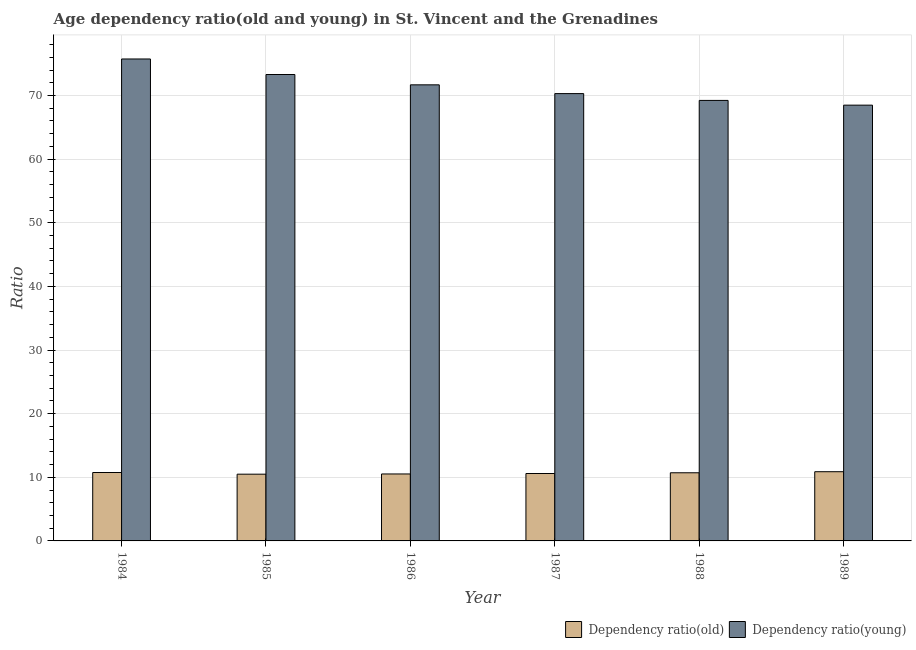Are the number of bars on each tick of the X-axis equal?
Make the answer very short. Yes. How many bars are there on the 6th tick from the right?
Your response must be concise. 2. What is the label of the 5th group of bars from the left?
Provide a short and direct response. 1988. In how many cases, is the number of bars for a given year not equal to the number of legend labels?
Make the answer very short. 0. What is the age dependency ratio(young) in 1987?
Your answer should be compact. 70.3. Across all years, what is the maximum age dependency ratio(old)?
Give a very brief answer. 10.88. Across all years, what is the minimum age dependency ratio(young)?
Offer a very short reply. 68.48. In which year was the age dependency ratio(old) minimum?
Offer a very short reply. 1985. What is the total age dependency ratio(young) in the graph?
Offer a very short reply. 428.73. What is the difference between the age dependency ratio(young) in 1986 and that in 1989?
Offer a very short reply. 3.19. What is the difference between the age dependency ratio(young) in 1985 and the age dependency ratio(old) in 1987?
Keep it short and to the point. 3. What is the average age dependency ratio(young) per year?
Ensure brevity in your answer.  71.46. In the year 1984, what is the difference between the age dependency ratio(old) and age dependency ratio(young)?
Give a very brief answer. 0. In how many years, is the age dependency ratio(old) greater than 26?
Offer a terse response. 0. What is the ratio of the age dependency ratio(old) in 1985 to that in 1989?
Make the answer very short. 0.96. Is the age dependency ratio(old) in 1985 less than that in 1987?
Provide a short and direct response. Yes. Is the difference between the age dependency ratio(old) in 1988 and 1989 greater than the difference between the age dependency ratio(young) in 1988 and 1989?
Your answer should be very brief. No. What is the difference between the highest and the second highest age dependency ratio(old)?
Offer a very short reply. 0.13. What is the difference between the highest and the lowest age dependency ratio(young)?
Offer a terse response. 7.26. Is the sum of the age dependency ratio(young) in 1984 and 1985 greater than the maximum age dependency ratio(old) across all years?
Offer a very short reply. Yes. What does the 1st bar from the left in 1989 represents?
Give a very brief answer. Dependency ratio(old). What does the 1st bar from the right in 1986 represents?
Give a very brief answer. Dependency ratio(young). How many bars are there?
Provide a succinct answer. 12. Are all the bars in the graph horizontal?
Offer a very short reply. No. How many years are there in the graph?
Provide a succinct answer. 6. What is the difference between two consecutive major ticks on the Y-axis?
Your response must be concise. 10. Does the graph contain grids?
Give a very brief answer. Yes. Where does the legend appear in the graph?
Offer a terse response. Bottom right. What is the title of the graph?
Your answer should be very brief. Age dependency ratio(old and young) in St. Vincent and the Grenadines. What is the label or title of the Y-axis?
Make the answer very short. Ratio. What is the Ratio in Dependency ratio(old) in 1984?
Provide a short and direct response. 10.75. What is the Ratio of Dependency ratio(young) in 1984?
Your response must be concise. 75.74. What is the Ratio in Dependency ratio(old) in 1985?
Make the answer very short. 10.49. What is the Ratio in Dependency ratio(young) in 1985?
Offer a very short reply. 73.3. What is the Ratio in Dependency ratio(old) in 1986?
Ensure brevity in your answer.  10.52. What is the Ratio of Dependency ratio(young) in 1986?
Provide a short and direct response. 71.68. What is the Ratio in Dependency ratio(old) in 1987?
Keep it short and to the point. 10.59. What is the Ratio in Dependency ratio(young) in 1987?
Offer a very short reply. 70.3. What is the Ratio in Dependency ratio(old) in 1988?
Keep it short and to the point. 10.71. What is the Ratio of Dependency ratio(young) in 1988?
Provide a succinct answer. 69.23. What is the Ratio of Dependency ratio(old) in 1989?
Your answer should be very brief. 10.88. What is the Ratio of Dependency ratio(young) in 1989?
Provide a succinct answer. 68.48. Across all years, what is the maximum Ratio in Dependency ratio(old)?
Your answer should be very brief. 10.88. Across all years, what is the maximum Ratio in Dependency ratio(young)?
Provide a succinct answer. 75.74. Across all years, what is the minimum Ratio in Dependency ratio(old)?
Make the answer very short. 10.49. Across all years, what is the minimum Ratio in Dependency ratio(young)?
Ensure brevity in your answer.  68.48. What is the total Ratio in Dependency ratio(old) in the graph?
Offer a terse response. 63.95. What is the total Ratio of Dependency ratio(young) in the graph?
Your response must be concise. 428.73. What is the difference between the Ratio in Dependency ratio(old) in 1984 and that in 1985?
Offer a very short reply. 0.26. What is the difference between the Ratio in Dependency ratio(young) in 1984 and that in 1985?
Make the answer very short. 2.44. What is the difference between the Ratio of Dependency ratio(old) in 1984 and that in 1986?
Give a very brief answer. 0.23. What is the difference between the Ratio of Dependency ratio(young) in 1984 and that in 1986?
Ensure brevity in your answer.  4.06. What is the difference between the Ratio in Dependency ratio(old) in 1984 and that in 1987?
Offer a very short reply. 0.16. What is the difference between the Ratio in Dependency ratio(young) in 1984 and that in 1987?
Your answer should be very brief. 5.44. What is the difference between the Ratio in Dependency ratio(old) in 1984 and that in 1988?
Offer a very short reply. 0.04. What is the difference between the Ratio in Dependency ratio(young) in 1984 and that in 1988?
Your response must be concise. 6.51. What is the difference between the Ratio of Dependency ratio(old) in 1984 and that in 1989?
Provide a short and direct response. -0.13. What is the difference between the Ratio in Dependency ratio(young) in 1984 and that in 1989?
Offer a very short reply. 7.26. What is the difference between the Ratio in Dependency ratio(old) in 1985 and that in 1986?
Ensure brevity in your answer.  -0.03. What is the difference between the Ratio of Dependency ratio(young) in 1985 and that in 1986?
Provide a short and direct response. 1.62. What is the difference between the Ratio of Dependency ratio(old) in 1985 and that in 1987?
Provide a succinct answer. -0.11. What is the difference between the Ratio in Dependency ratio(young) in 1985 and that in 1987?
Offer a terse response. 3. What is the difference between the Ratio of Dependency ratio(old) in 1985 and that in 1988?
Offer a very short reply. -0.22. What is the difference between the Ratio of Dependency ratio(young) in 1985 and that in 1988?
Offer a terse response. 4.07. What is the difference between the Ratio in Dependency ratio(old) in 1985 and that in 1989?
Your answer should be compact. -0.39. What is the difference between the Ratio of Dependency ratio(young) in 1985 and that in 1989?
Give a very brief answer. 4.82. What is the difference between the Ratio in Dependency ratio(old) in 1986 and that in 1987?
Your answer should be very brief. -0.07. What is the difference between the Ratio of Dependency ratio(young) in 1986 and that in 1987?
Your response must be concise. 1.38. What is the difference between the Ratio of Dependency ratio(old) in 1986 and that in 1988?
Your answer should be very brief. -0.19. What is the difference between the Ratio in Dependency ratio(young) in 1986 and that in 1988?
Your answer should be compact. 2.45. What is the difference between the Ratio in Dependency ratio(old) in 1986 and that in 1989?
Offer a terse response. -0.35. What is the difference between the Ratio in Dependency ratio(young) in 1986 and that in 1989?
Ensure brevity in your answer.  3.19. What is the difference between the Ratio of Dependency ratio(old) in 1987 and that in 1988?
Your response must be concise. -0.12. What is the difference between the Ratio of Dependency ratio(young) in 1987 and that in 1988?
Offer a very short reply. 1.07. What is the difference between the Ratio in Dependency ratio(old) in 1987 and that in 1989?
Your answer should be compact. -0.28. What is the difference between the Ratio in Dependency ratio(young) in 1987 and that in 1989?
Your answer should be very brief. 1.81. What is the difference between the Ratio in Dependency ratio(old) in 1988 and that in 1989?
Your answer should be compact. -0.17. What is the difference between the Ratio in Dependency ratio(young) in 1988 and that in 1989?
Offer a very short reply. 0.74. What is the difference between the Ratio in Dependency ratio(old) in 1984 and the Ratio in Dependency ratio(young) in 1985?
Offer a terse response. -62.55. What is the difference between the Ratio of Dependency ratio(old) in 1984 and the Ratio of Dependency ratio(young) in 1986?
Make the answer very short. -60.92. What is the difference between the Ratio of Dependency ratio(old) in 1984 and the Ratio of Dependency ratio(young) in 1987?
Offer a very short reply. -59.55. What is the difference between the Ratio of Dependency ratio(old) in 1984 and the Ratio of Dependency ratio(young) in 1988?
Ensure brevity in your answer.  -58.48. What is the difference between the Ratio in Dependency ratio(old) in 1984 and the Ratio in Dependency ratio(young) in 1989?
Ensure brevity in your answer.  -57.73. What is the difference between the Ratio of Dependency ratio(old) in 1985 and the Ratio of Dependency ratio(young) in 1986?
Ensure brevity in your answer.  -61.19. What is the difference between the Ratio of Dependency ratio(old) in 1985 and the Ratio of Dependency ratio(young) in 1987?
Give a very brief answer. -59.81. What is the difference between the Ratio of Dependency ratio(old) in 1985 and the Ratio of Dependency ratio(young) in 1988?
Make the answer very short. -58.74. What is the difference between the Ratio in Dependency ratio(old) in 1985 and the Ratio in Dependency ratio(young) in 1989?
Provide a short and direct response. -57.99. What is the difference between the Ratio of Dependency ratio(old) in 1986 and the Ratio of Dependency ratio(young) in 1987?
Ensure brevity in your answer.  -59.78. What is the difference between the Ratio of Dependency ratio(old) in 1986 and the Ratio of Dependency ratio(young) in 1988?
Your response must be concise. -58.71. What is the difference between the Ratio of Dependency ratio(old) in 1986 and the Ratio of Dependency ratio(young) in 1989?
Your answer should be very brief. -57.96. What is the difference between the Ratio of Dependency ratio(old) in 1987 and the Ratio of Dependency ratio(young) in 1988?
Offer a very short reply. -58.63. What is the difference between the Ratio in Dependency ratio(old) in 1987 and the Ratio in Dependency ratio(young) in 1989?
Offer a terse response. -57.89. What is the difference between the Ratio of Dependency ratio(old) in 1988 and the Ratio of Dependency ratio(young) in 1989?
Your answer should be compact. -57.77. What is the average Ratio in Dependency ratio(old) per year?
Give a very brief answer. 10.66. What is the average Ratio of Dependency ratio(young) per year?
Give a very brief answer. 71.46. In the year 1984, what is the difference between the Ratio of Dependency ratio(old) and Ratio of Dependency ratio(young)?
Provide a short and direct response. -64.99. In the year 1985, what is the difference between the Ratio of Dependency ratio(old) and Ratio of Dependency ratio(young)?
Provide a succinct answer. -62.81. In the year 1986, what is the difference between the Ratio in Dependency ratio(old) and Ratio in Dependency ratio(young)?
Provide a succinct answer. -61.15. In the year 1987, what is the difference between the Ratio in Dependency ratio(old) and Ratio in Dependency ratio(young)?
Your answer should be compact. -59.7. In the year 1988, what is the difference between the Ratio in Dependency ratio(old) and Ratio in Dependency ratio(young)?
Provide a short and direct response. -58.52. In the year 1989, what is the difference between the Ratio of Dependency ratio(old) and Ratio of Dependency ratio(young)?
Ensure brevity in your answer.  -57.61. What is the ratio of the Ratio in Dependency ratio(old) in 1984 to that in 1985?
Make the answer very short. 1.02. What is the ratio of the Ratio in Dependency ratio(young) in 1984 to that in 1985?
Ensure brevity in your answer.  1.03. What is the ratio of the Ratio in Dependency ratio(old) in 1984 to that in 1986?
Provide a short and direct response. 1.02. What is the ratio of the Ratio in Dependency ratio(young) in 1984 to that in 1986?
Offer a terse response. 1.06. What is the ratio of the Ratio in Dependency ratio(old) in 1984 to that in 1987?
Give a very brief answer. 1.01. What is the ratio of the Ratio in Dependency ratio(young) in 1984 to that in 1987?
Provide a short and direct response. 1.08. What is the ratio of the Ratio of Dependency ratio(old) in 1984 to that in 1988?
Your answer should be very brief. 1. What is the ratio of the Ratio in Dependency ratio(young) in 1984 to that in 1988?
Give a very brief answer. 1.09. What is the ratio of the Ratio in Dependency ratio(old) in 1984 to that in 1989?
Offer a very short reply. 0.99. What is the ratio of the Ratio in Dependency ratio(young) in 1984 to that in 1989?
Ensure brevity in your answer.  1.11. What is the ratio of the Ratio in Dependency ratio(young) in 1985 to that in 1986?
Your response must be concise. 1.02. What is the ratio of the Ratio in Dependency ratio(old) in 1985 to that in 1987?
Offer a terse response. 0.99. What is the ratio of the Ratio of Dependency ratio(young) in 1985 to that in 1987?
Your answer should be very brief. 1.04. What is the ratio of the Ratio of Dependency ratio(old) in 1985 to that in 1988?
Make the answer very short. 0.98. What is the ratio of the Ratio of Dependency ratio(young) in 1985 to that in 1988?
Offer a terse response. 1.06. What is the ratio of the Ratio in Dependency ratio(old) in 1985 to that in 1989?
Offer a terse response. 0.96. What is the ratio of the Ratio of Dependency ratio(young) in 1985 to that in 1989?
Offer a very short reply. 1.07. What is the ratio of the Ratio in Dependency ratio(young) in 1986 to that in 1987?
Offer a very short reply. 1.02. What is the ratio of the Ratio in Dependency ratio(old) in 1986 to that in 1988?
Give a very brief answer. 0.98. What is the ratio of the Ratio in Dependency ratio(young) in 1986 to that in 1988?
Give a very brief answer. 1.04. What is the ratio of the Ratio of Dependency ratio(old) in 1986 to that in 1989?
Provide a short and direct response. 0.97. What is the ratio of the Ratio in Dependency ratio(young) in 1986 to that in 1989?
Provide a succinct answer. 1.05. What is the ratio of the Ratio of Dependency ratio(old) in 1987 to that in 1988?
Ensure brevity in your answer.  0.99. What is the ratio of the Ratio in Dependency ratio(young) in 1987 to that in 1988?
Offer a terse response. 1.02. What is the ratio of the Ratio of Dependency ratio(young) in 1987 to that in 1989?
Your answer should be very brief. 1.03. What is the ratio of the Ratio of Dependency ratio(old) in 1988 to that in 1989?
Provide a succinct answer. 0.98. What is the ratio of the Ratio of Dependency ratio(young) in 1988 to that in 1989?
Provide a succinct answer. 1.01. What is the difference between the highest and the second highest Ratio in Dependency ratio(old)?
Provide a succinct answer. 0.13. What is the difference between the highest and the second highest Ratio of Dependency ratio(young)?
Keep it short and to the point. 2.44. What is the difference between the highest and the lowest Ratio in Dependency ratio(old)?
Your answer should be compact. 0.39. What is the difference between the highest and the lowest Ratio of Dependency ratio(young)?
Your response must be concise. 7.26. 